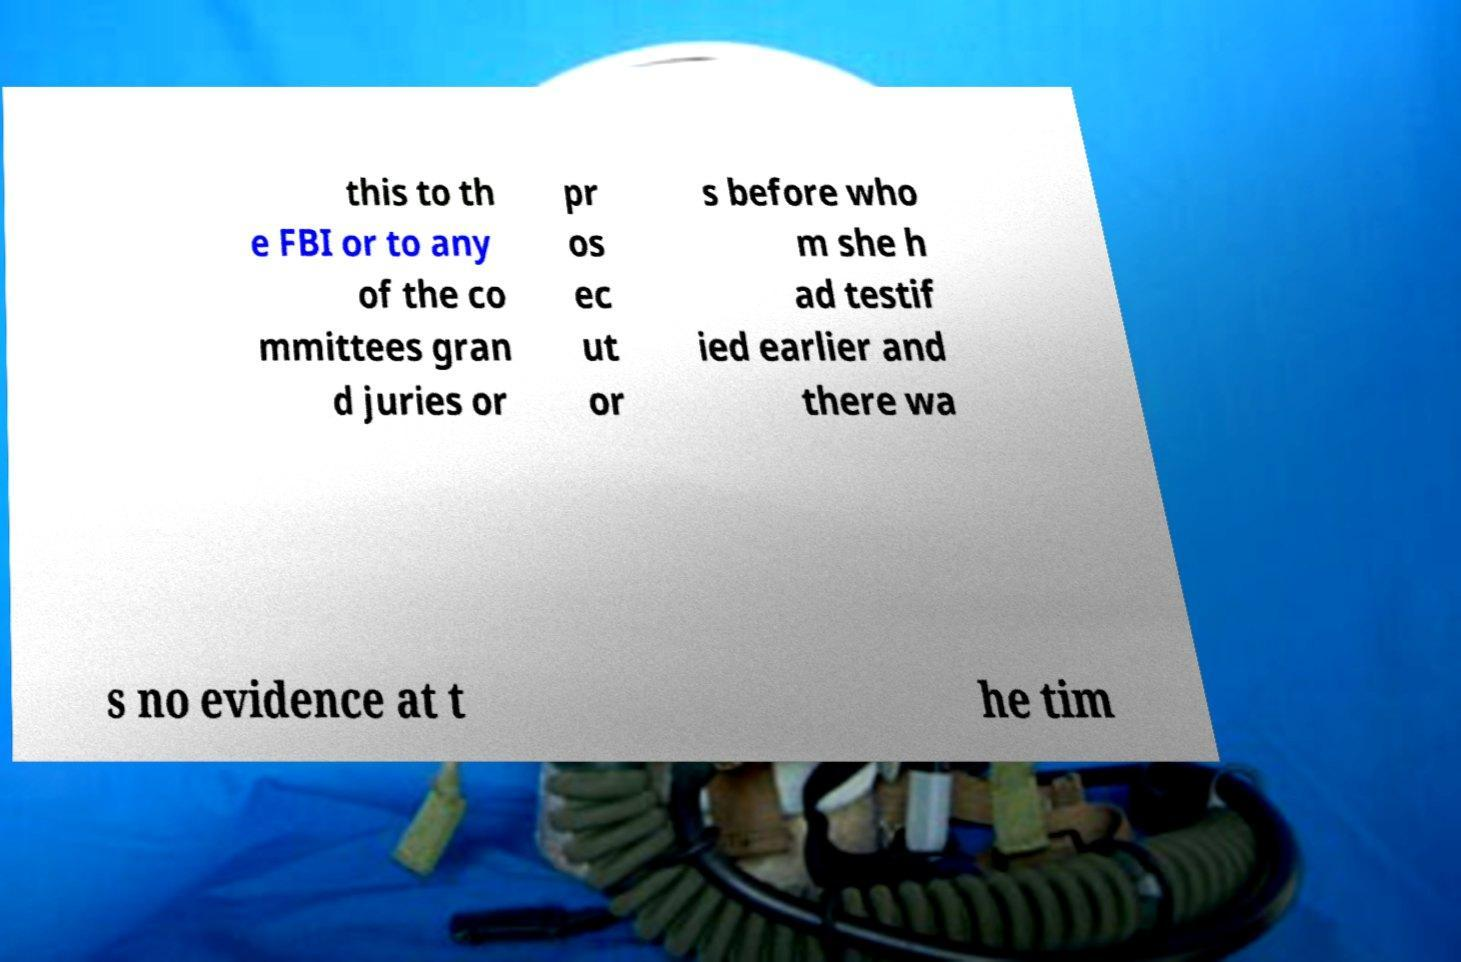Could you extract and type out the text from this image? this to th e FBI or to any of the co mmittees gran d juries or pr os ec ut or s before who m she h ad testif ied earlier and there wa s no evidence at t he tim 